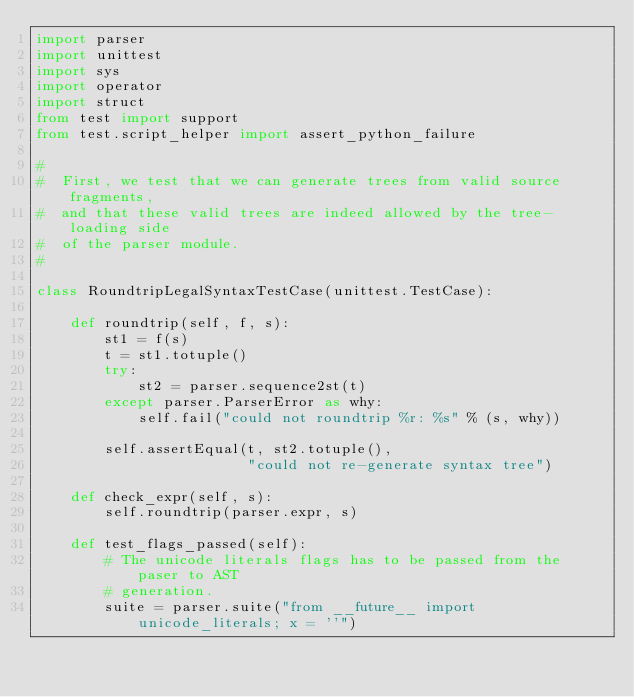Convert code to text. <code><loc_0><loc_0><loc_500><loc_500><_Python_>import parser
import unittest
import sys
import operator
import struct
from test import support
from test.script_helper import assert_python_failure

#
#  First, we test that we can generate trees from valid source fragments,
#  and that these valid trees are indeed allowed by the tree-loading side
#  of the parser module.
#

class RoundtripLegalSyntaxTestCase(unittest.TestCase):

    def roundtrip(self, f, s):
        st1 = f(s)
        t = st1.totuple()
        try:
            st2 = parser.sequence2st(t)
        except parser.ParserError as why:
            self.fail("could not roundtrip %r: %s" % (s, why))

        self.assertEqual(t, st2.totuple(),
                         "could not re-generate syntax tree")

    def check_expr(self, s):
        self.roundtrip(parser.expr, s)

    def test_flags_passed(self):
        # The unicode literals flags has to be passed from the paser to AST
        # generation.
        suite = parser.suite("from __future__ import unicode_literals; x = ''")</code> 